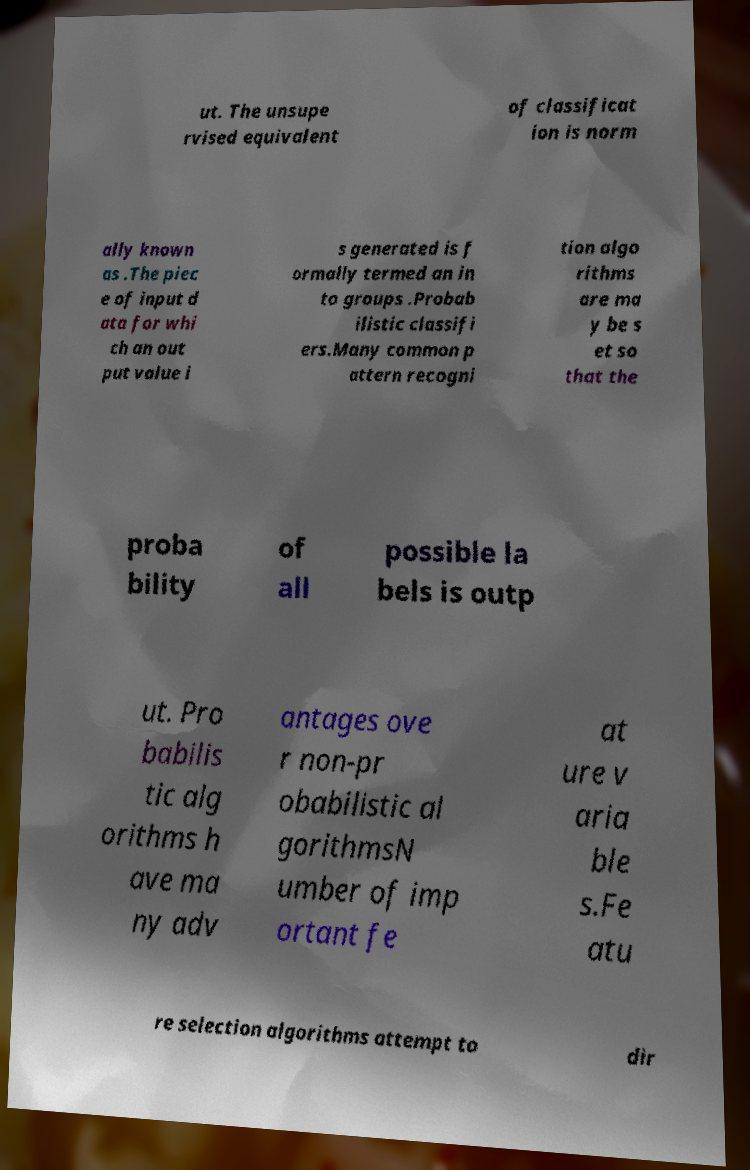Please read and relay the text visible in this image. What does it say? ut. The unsupe rvised equivalent of classificat ion is norm ally known as .The piec e of input d ata for whi ch an out put value i s generated is f ormally termed an in to groups .Probab ilistic classifi ers.Many common p attern recogni tion algo rithms are ma y be s et so that the proba bility of all possible la bels is outp ut. Pro babilis tic alg orithms h ave ma ny adv antages ove r non-pr obabilistic al gorithmsN umber of imp ortant fe at ure v aria ble s.Fe atu re selection algorithms attempt to dir 